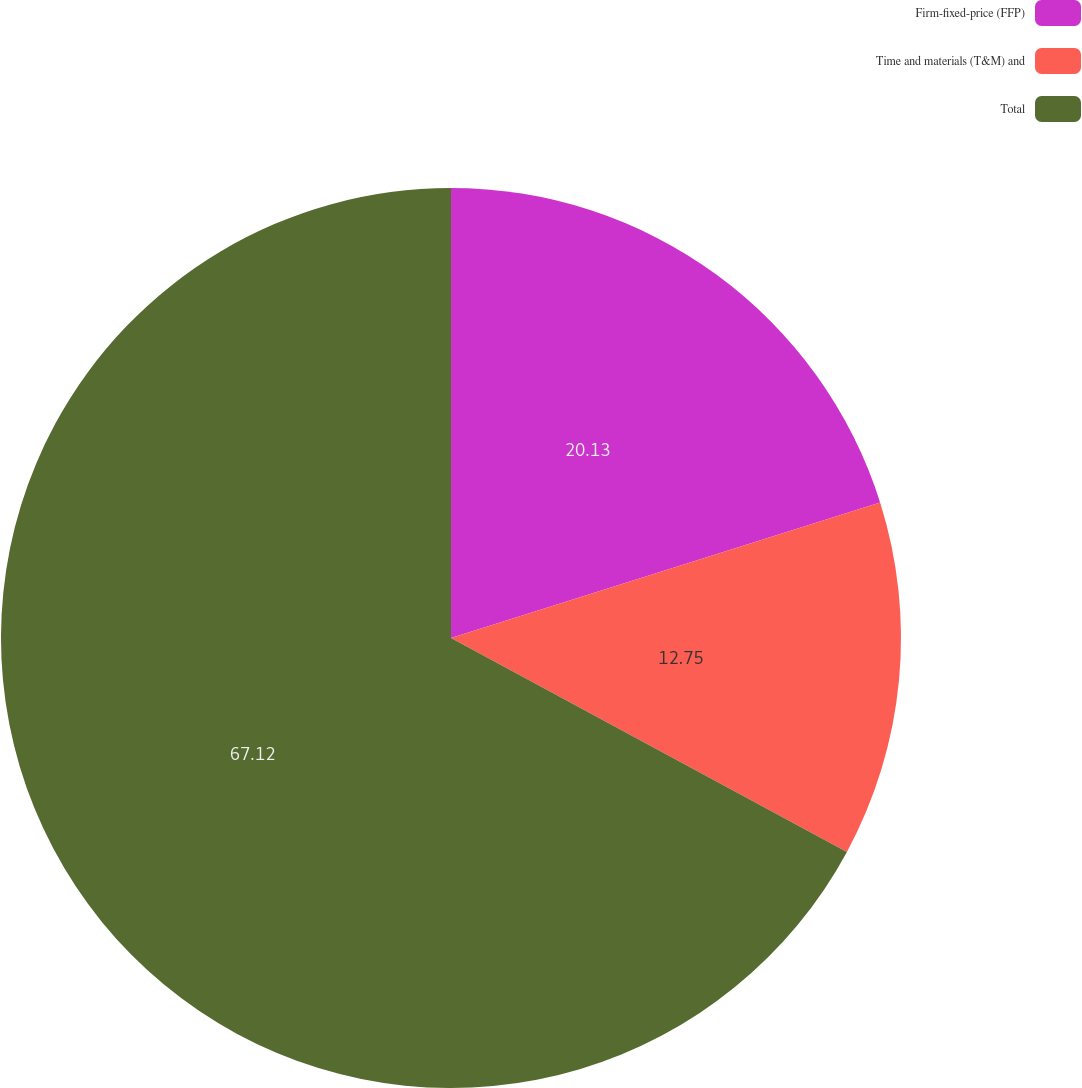<chart> <loc_0><loc_0><loc_500><loc_500><pie_chart><fcel>Firm-fixed-price (FFP)<fcel>Time and materials (T&M) and<fcel>Total<nl><fcel>20.13%<fcel>12.75%<fcel>67.11%<nl></chart> 